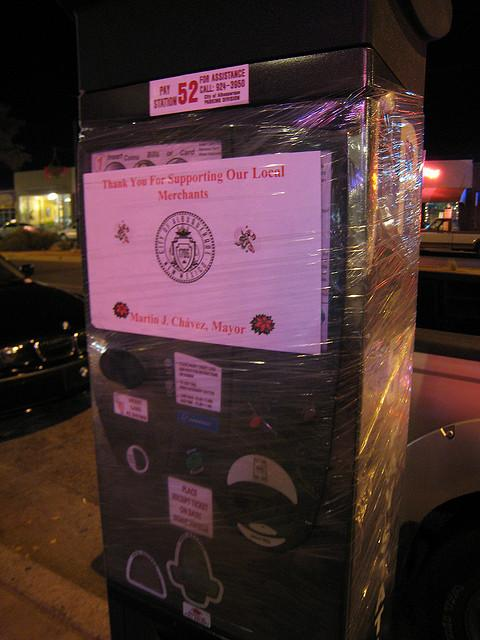This machine is meant to assist what type people in payments? parking 